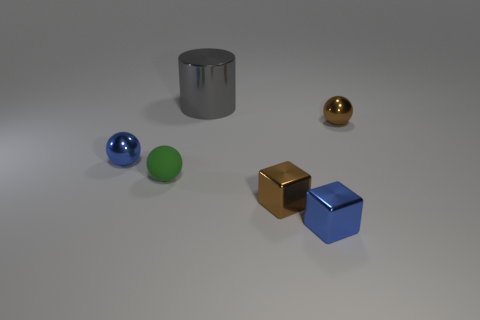Add 2 large metal blocks. How many objects exist? 8 Subtract all cylinders. How many objects are left? 5 Subtract 0 yellow cylinders. How many objects are left? 6 Subtract all small blue metallic spheres. Subtract all blue metallic cubes. How many objects are left? 4 Add 3 tiny green rubber spheres. How many tiny green rubber spheres are left? 4 Add 5 tiny cyan shiny cubes. How many tiny cyan shiny cubes exist? 5 